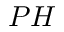<formula> <loc_0><loc_0><loc_500><loc_500>P H</formula> 